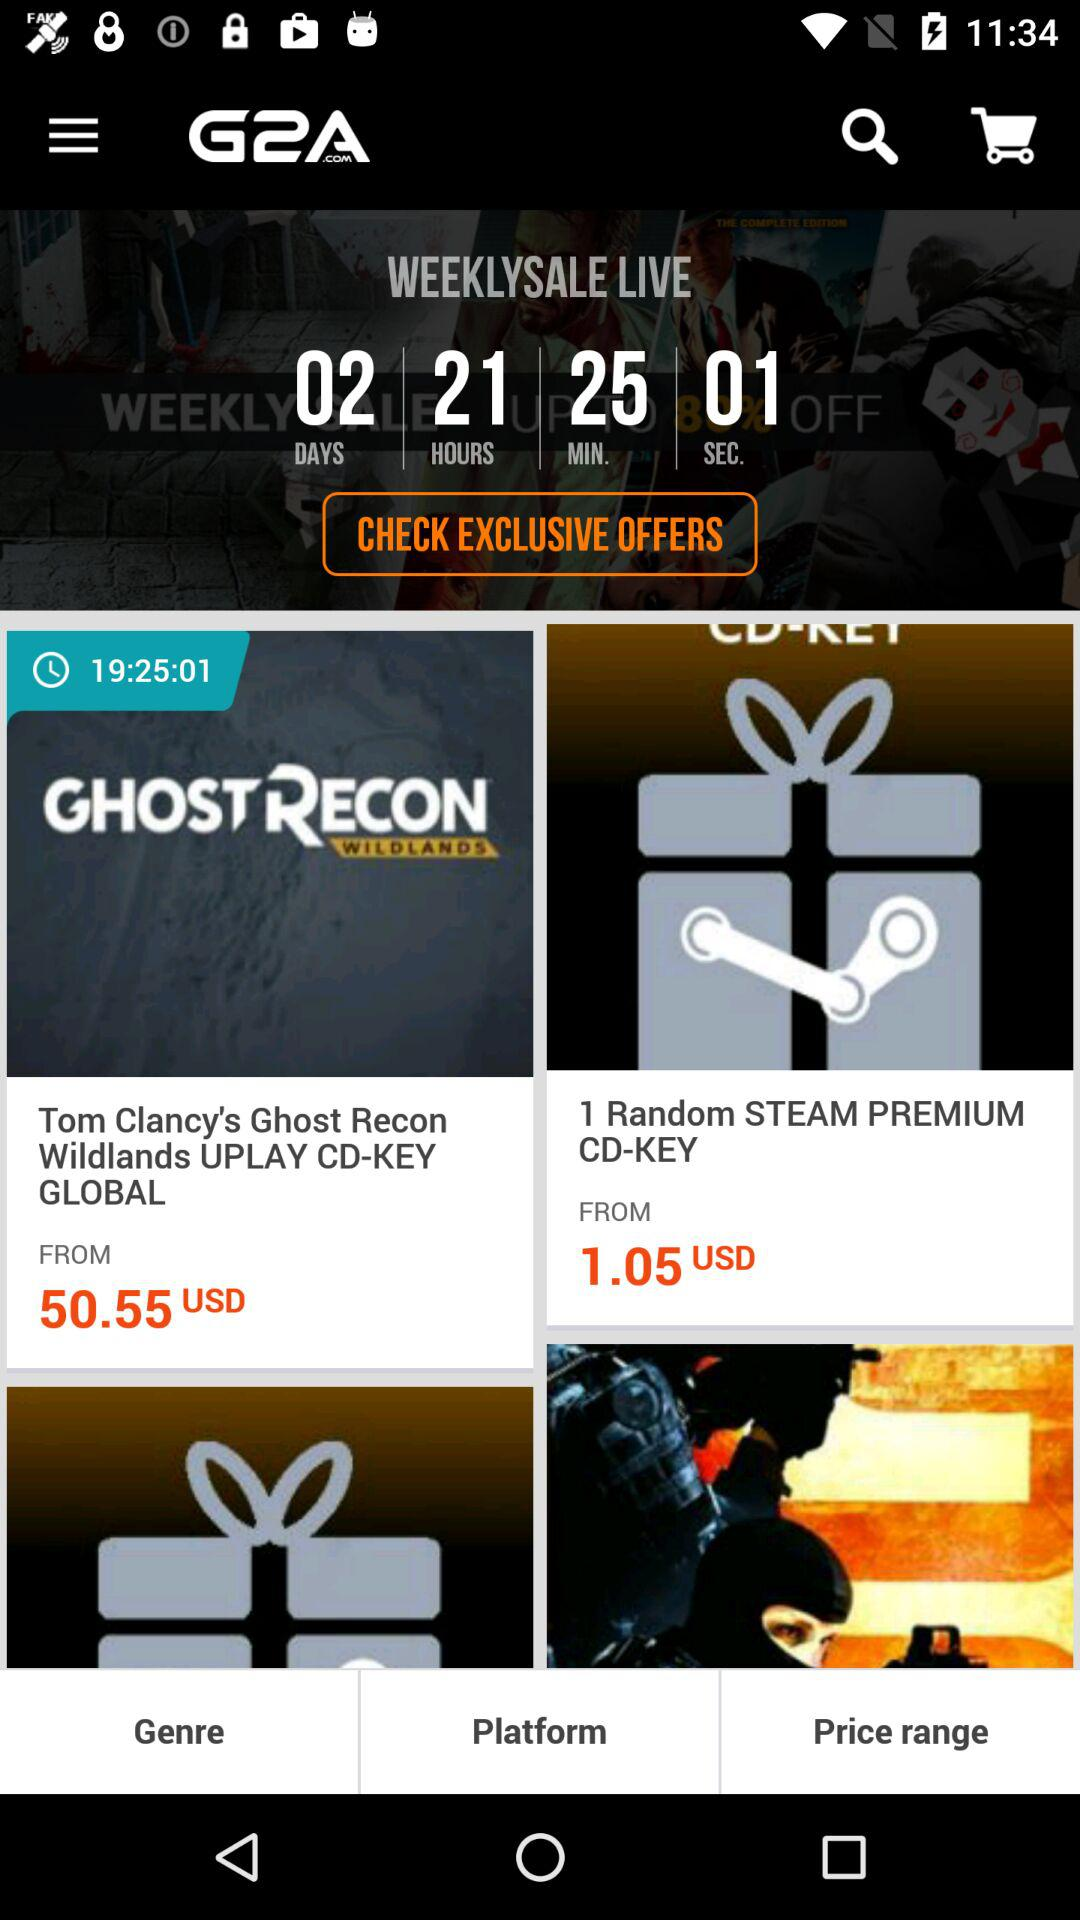How much does Tom Clancy's Ghost Recon Wildlands Uplay CD-KEY Global cost? Tom Clancy's Ghost Recon Wildlands Uplay CD-KEY Global costs 50.55 USD. 